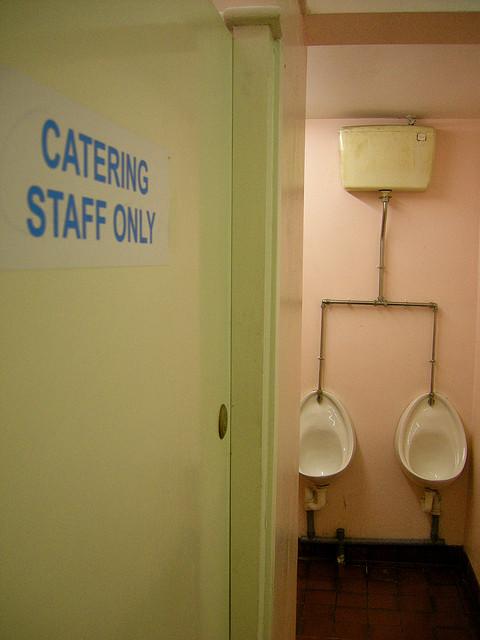Is the light in the bathroom on?
Quick response, please. Yes. What is on the wall?
Write a very short answer. Catering staff only. Is this a waiting area?
Answer briefly. No. What color is the wall that the urinals are on?
Short answer required. Pink. What is written on the shutter?
Write a very short answer. Catering staff only. How many screws are in the door?
Give a very brief answer. 0. How many toilets are in the bathroom?
Answer briefly. 2. How many bowls are in the picture?
Short answer required. 2. Has the wall been freshly painted?
Give a very brief answer. No. What color is the door?
Quick response, please. White. What kind of piping is being used underneath these urinals?
Answer briefly. Plumbing. Where is the Abbey Road sign?
Write a very short answer. Outside. How many toilets are there?
Give a very brief answer. 2. What is painted on the left wall?
Be succinct. Catering staff only. Is this for staff only?
Quick response, please. Yes. Is this photo geometrically pleasing?
Write a very short answer. No. What's hanging on the walls?
Answer briefly. Urinals. 